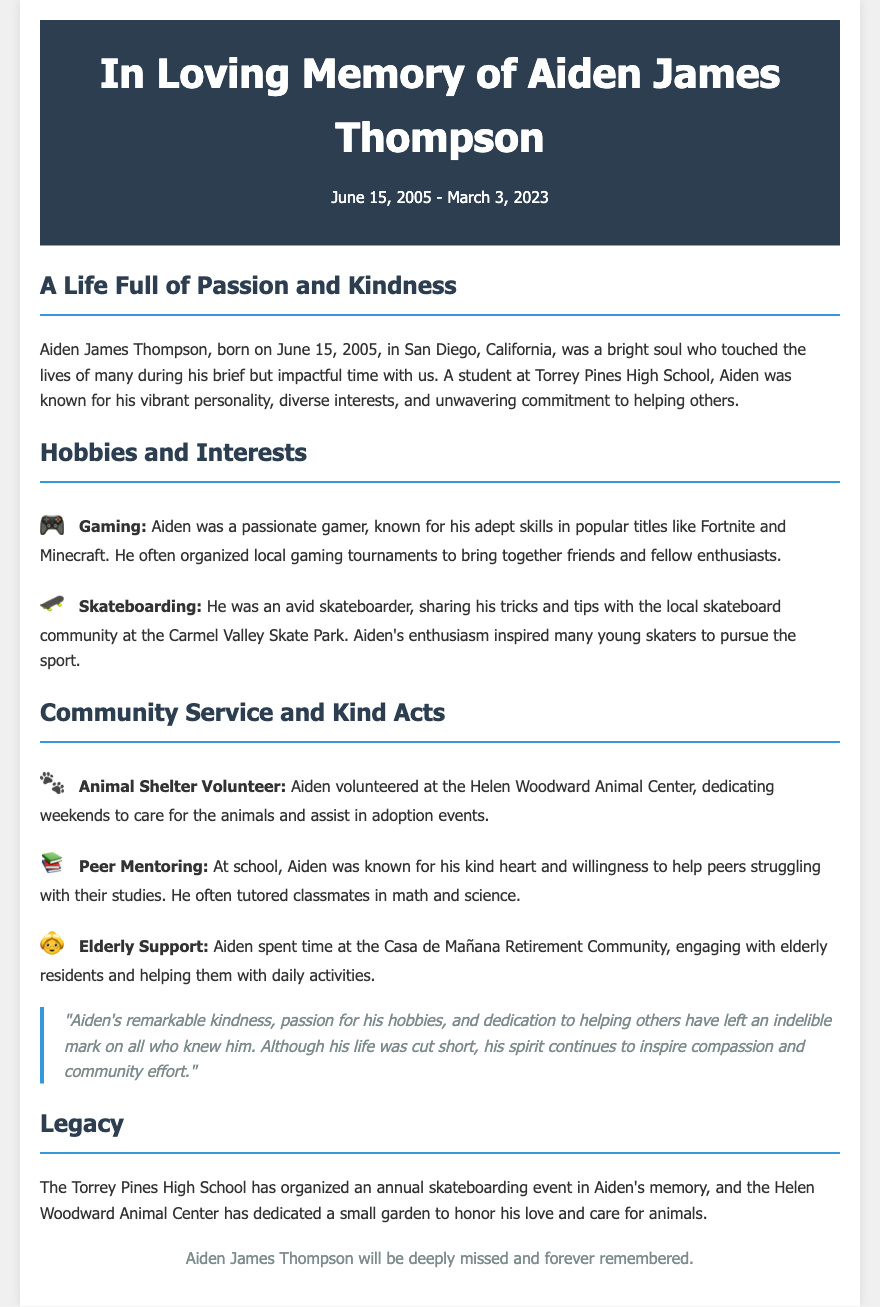What was Aiden's birth date? Aiden's birth date is mentioned in the header of the document.
Answer: June 15, 2005 In which city was Aiden born? The document states that Aiden was born in San Diego, California.
Answer: San Diego, California What school did Aiden attend? Aiden was a student at the school mentioned in the section on his life and contributions.
Answer: Torrey Pines High School Which animal center did Aiden volunteer at? The document specifies the name of the animal center where Aiden dedicated his weekends.
Answer: Helen Woodward Animal Center What sport was Aiden passionate about? Aiden's interests include a specific sport highlighted in his hobbies section.
Answer: Skateboarding How did Aiden contribute to his community? The document outlines several acts of kindness and service Aiden was involved in.
Answer: Community service What event was organized in Aiden's memory? The legacy section details a specific event established to honor Aiden.
Answer: Annual skateboarding event What was Aiden's skill level in gaming? Aiden's gaming abilities and involvement are discussed, indicating his expertise.
Answer: Adept When did Aiden pass away? Aiden’s date of passing is included in the header of the document.
Answer: March 3, 2023 